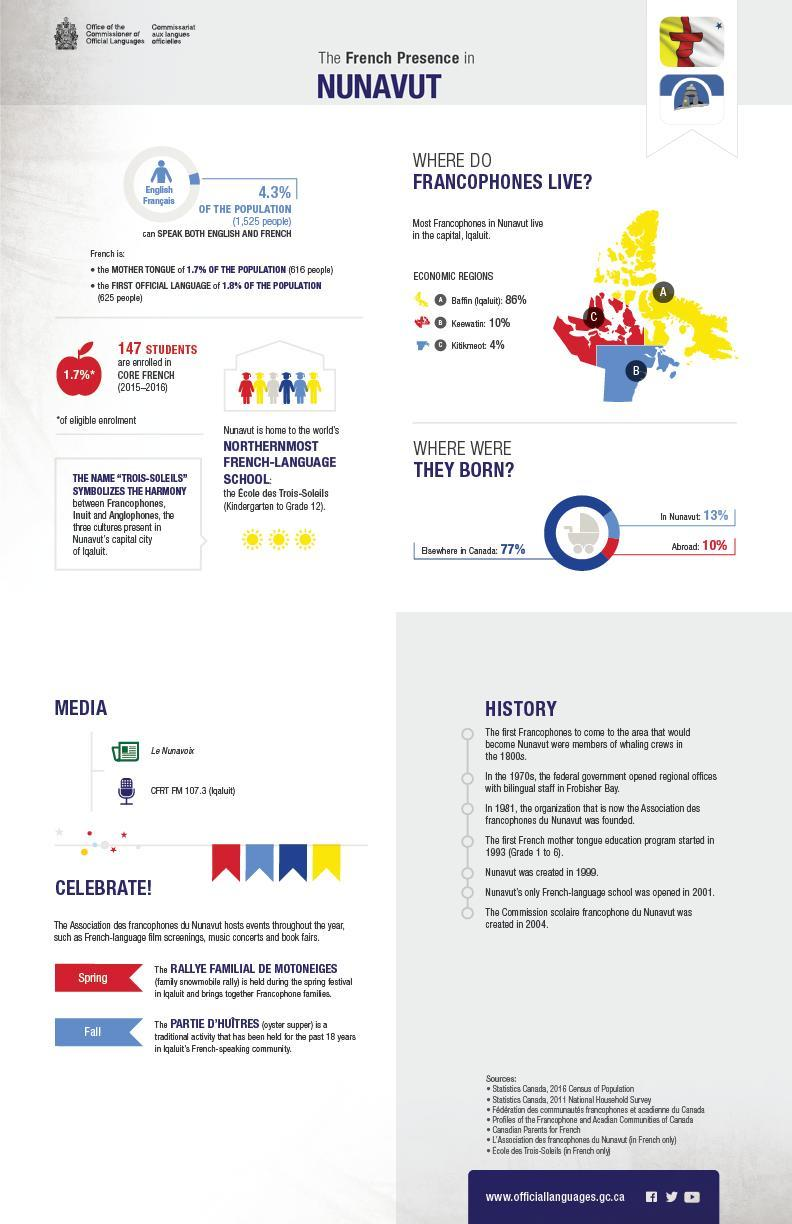How many economic regions mentioned in this infographic?
Answer the question with a short phrase. 3 